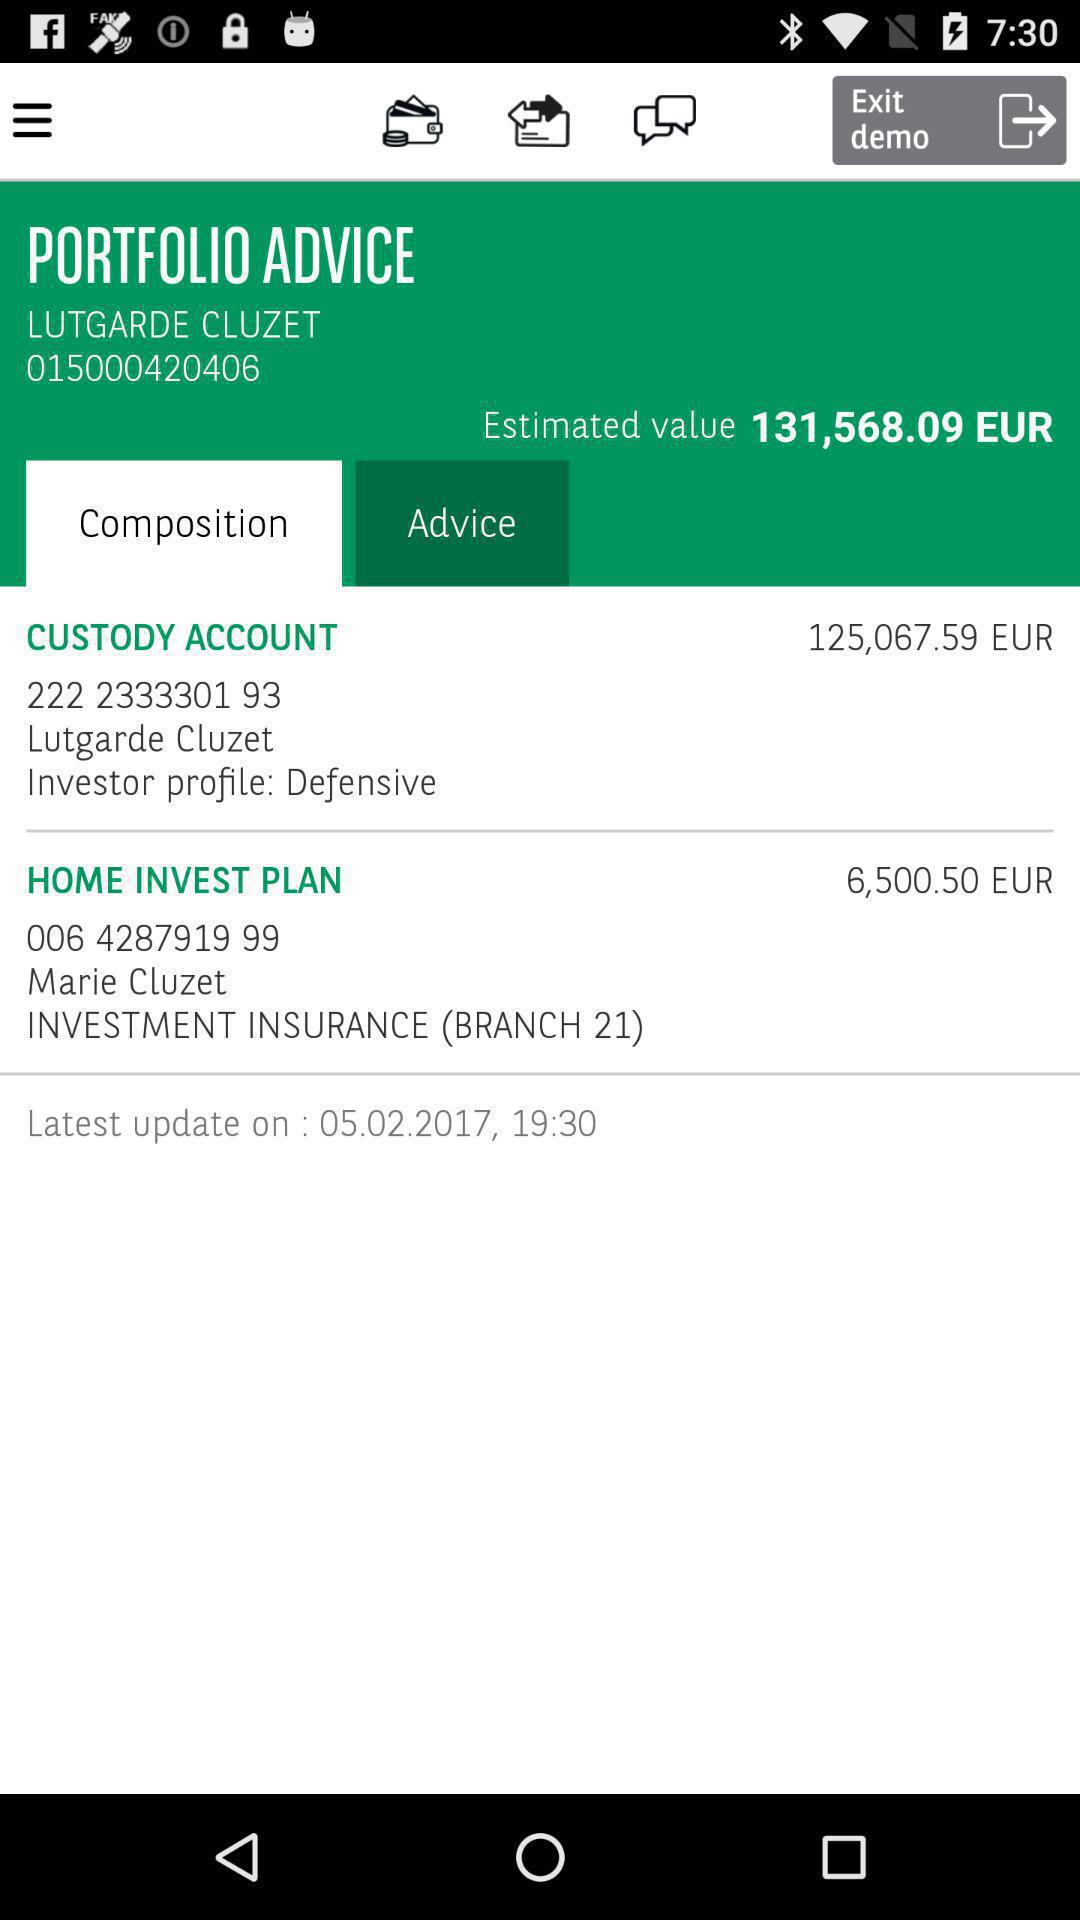What is the price of the "HOME INVEST PLAN"? The price of the "HOME INVEST PLAN" is 6,500.50 EUR. 